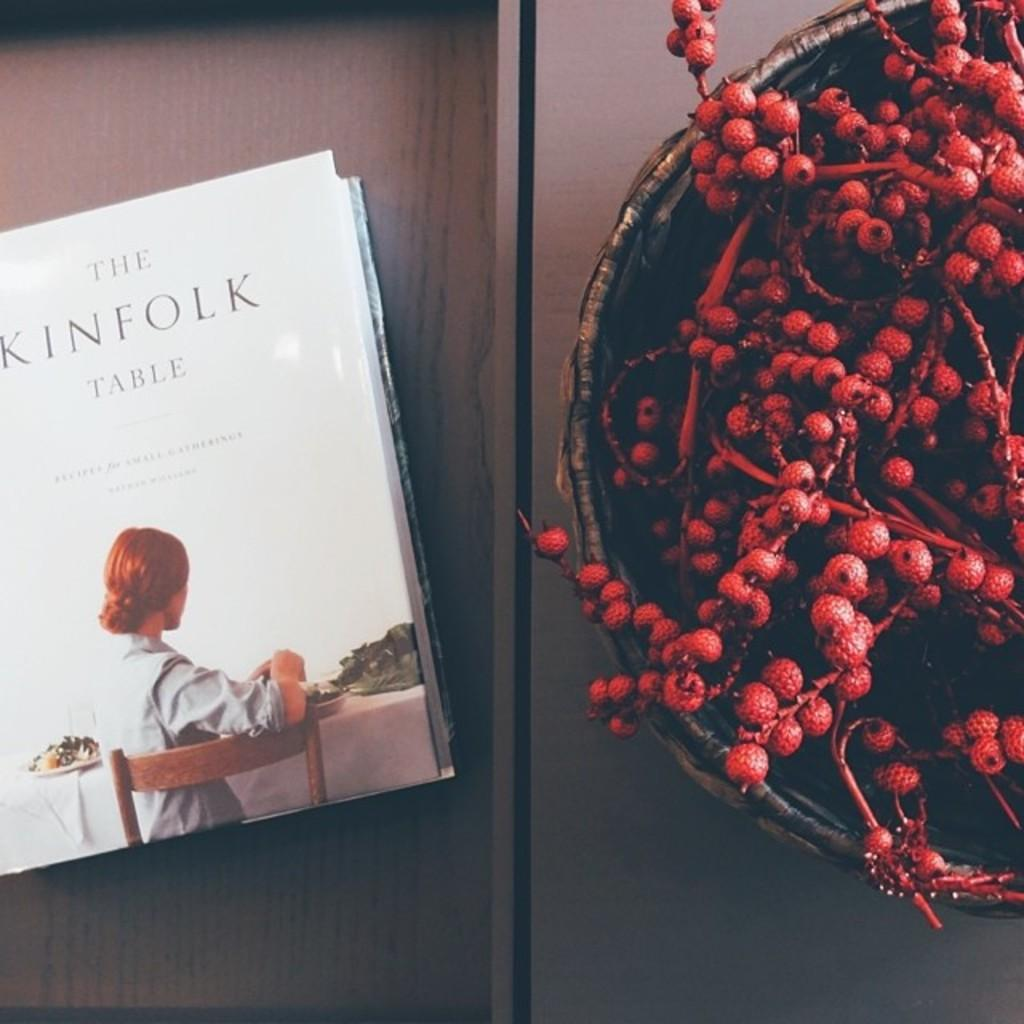<image>
Present a compact description of the photo's key features. A book called The Kinfolk Table is on a table next to a bowl full of red berries. 